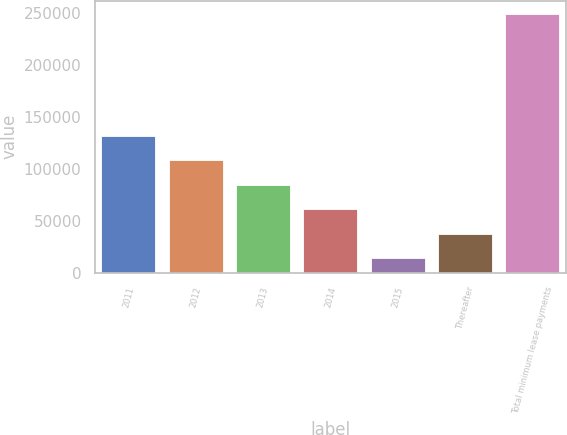Convert chart to OTSL. <chart><loc_0><loc_0><loc_500><loc_500><bar_chart><fcel>2011<fcel>2012<fcel>2013<fcel>2014<fcel>2015<fcel>Thereafter<fcel>Total minimum lease payments<nl><fcel>131590<fcel>108067<fcel>84544.5<fcel>61022<fcel>13977<fcel>37499.5<fcel>249202<nl></chart> 